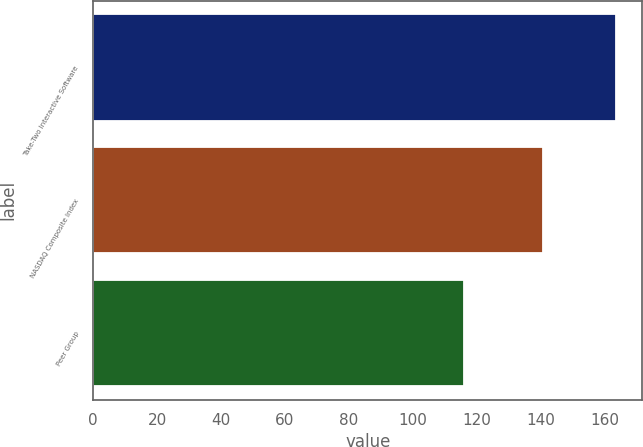Convert chart. <chart><loc_0><loc_0><loc_500><loc_500><bar_chart><fcel>Take-Two Interactive Software<fcel>NASDAQ Composite Index<fcel>Peer Group<nl><fcel>163.63<fcel>140.86<fcel>116.13<nl></chart> 